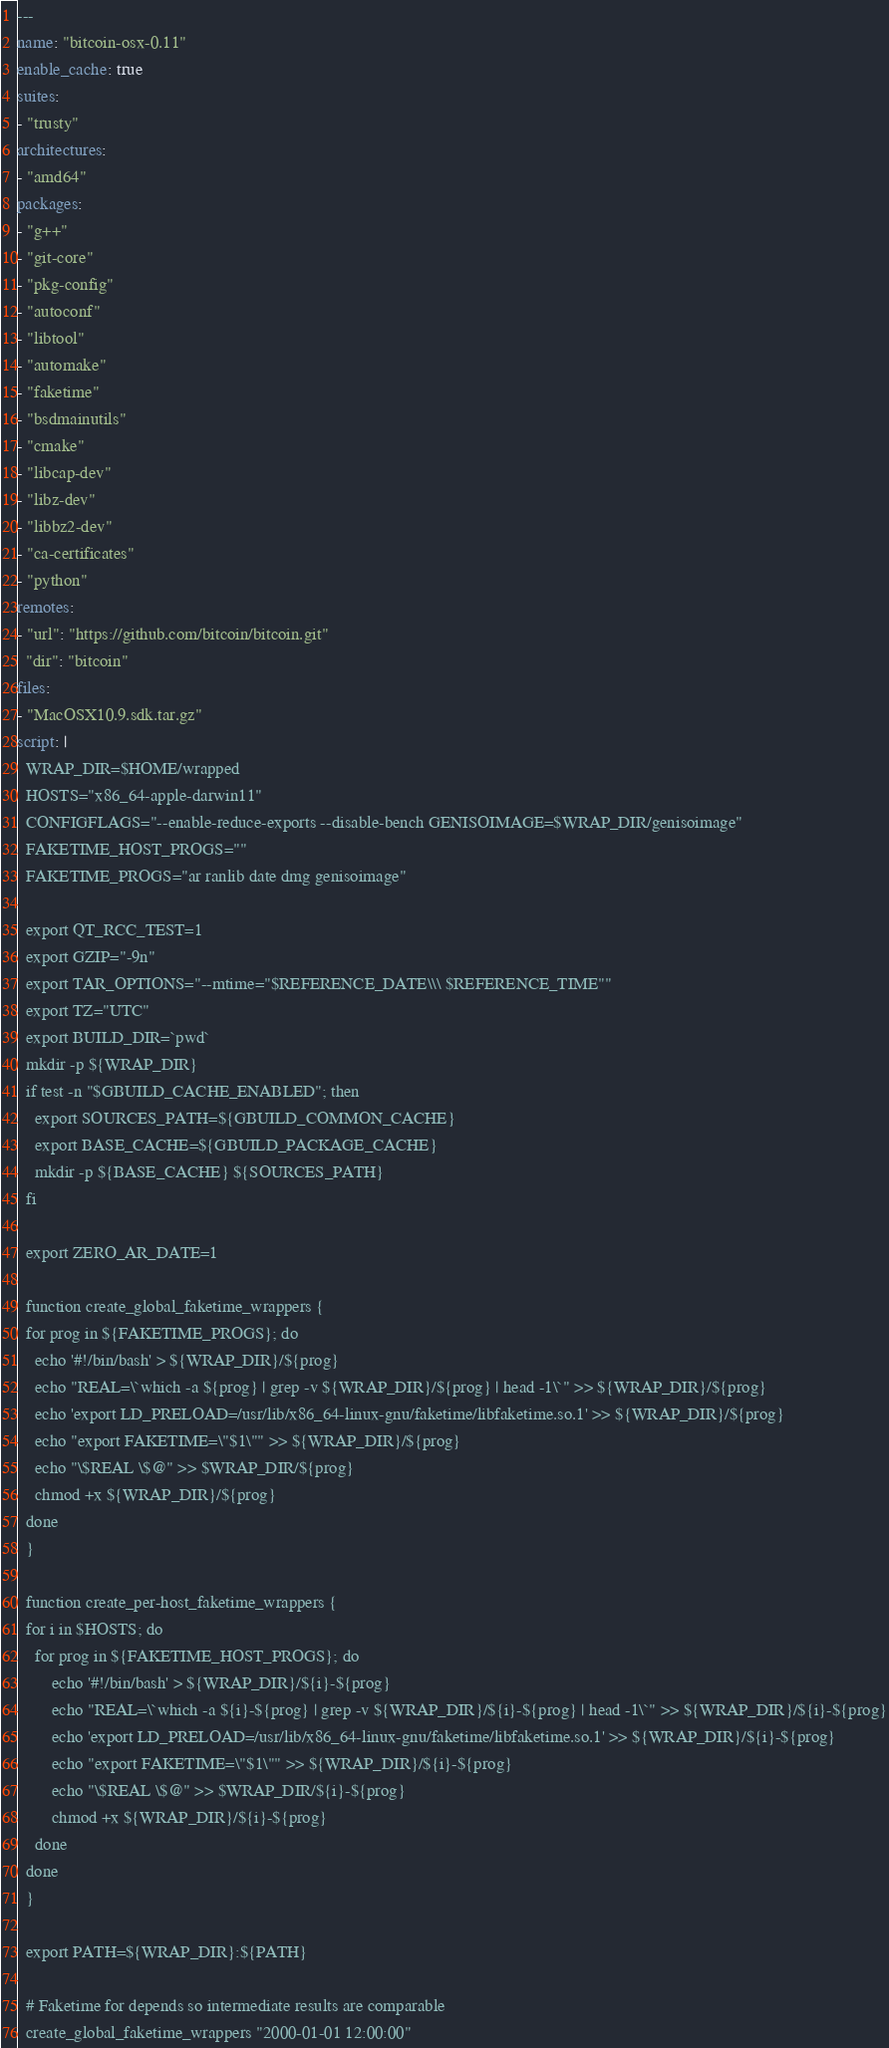<code> <loc_0><loc_0><loc_500><loc_500><_YAML_>---
name: "bitcoin-osx-0.11"
enable_cache: true
suites:
- "trusty"
architectures:
- "amd64"
packages:
- "g++"
- "git-core"
- "pkg-config"
- "autoconf"
- "libtool"
- "automake"
- "faketime"
- "bsdmainutils"
- "cmake"
- "libcap-dev"
- "libz-dev"
- "libbz2-dev"
- "ca-certificates"
- "python"
remotes:
- "url": "https://github.com/bitcoin/bitcoin.git"
  "dir": "bitcoin"
files:
- "MacOSX10.9.sdk.tar.gz"
script: |
  WRAP_DIR=$HOME/wrapped
  HOSTS="x86_64-apple-darwin11"
  CONFIGFLAGS="--enable-reduce-exports --disable-bench GENISOIMAGE=$WRAP_DIR/genisoimage"
  FAKETIME_HOST_PROGS=""
  FAKETIME_PROGS="ar ranlib date dmg genisoimage"

  export QT_RCC_TEST=1
  export GZIP="-9n"
  export TAR_OPTIONS="--mtime="$REFERENCE_DATE\\\ $REFERENCE_TIME""
  export TZ="UTC"
  export BUILD_DIR=`pwd`
  mkdir -p ${WRAP_DIR}
  if test -n "$GBUILD_CACHE_ENABLED"; then
    export SOURCES_PATH=${GBUILD_COMMON_CACHE}
    export BASE_CACHE=${GBUILD_PACKAGE_CACHE}
    mkdir -p ${BASE_CACHE} ${SOURCES_PATH}
  fi

  export ZERO_AR_DATE=1

  function create_global_faketime_wrappers {
  for prog in ${FAKETIME_PROGS}; do
    echo '#!/bin/bash' > ${WRAP_DIR}/${prog}
    echo "REAL=\`which -a ${prog} | grep -v ${WRAP_DIR}/${prog} | head -1\`" >> ${WRAP_DIR}/${prog}
    echo 'export LD_PRELOAD=/usr/lib/x86_64-linux-gnu/faketime/libfaketime.so.1' >> ${WRAP_DIR}/${prog}
    echo "export FAKETIME=\"$1\"" >> ${WRAP_DIR}/${prog}
    echo "\$REAL \$@" >> $WRAP_DIR/${prog}
    chmod +x ${WRAP_DIR}/${prog}
  done
  }

  function create_per-host_faketime_wrappers {
  for i in $HOSTS; do
    for prog in ${FAKETIME_HOST_PROGS}; do
        echo '#!/bin/bash' > ${WRAP_DIR}/${i}-${prog}
        echo "REAL=\`which -a ${i}-${prog} | grep -v ${WRAP_DIR}/${i}-${prog} | head -1\`" >> ${WRAP_DIR}/${i}-${prog}
        echo 'export LD_PRELOAD=/usr/lib/x86_64-linux-gnu/faketime/libfaketime.so.1' >> ${WRAP_DIR}/${i}-${prog}
        echo "export FAKETIME=\"$1\"" >> ${WRAP_DIR}/${i}-${prog}
        echo "\$REAL \$@" >> $WRAP_DIR/${i}-${prog}
        chmod +x ${WRAP_DIR}/${i}-${prog}
    done
  done
  }

  export PATH=${WRAP_DIR}:${PATH}

  # Faketime for depends so intermediate results are comparable
  create_global_faketime_wrappers "2000-01-01 12:00:00"</code> 